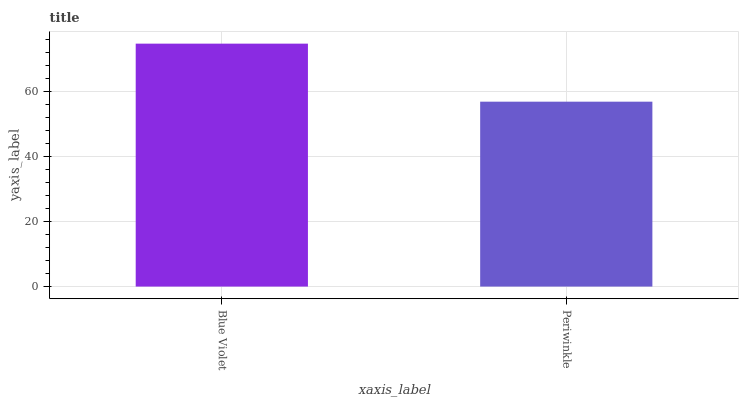Is Periwinkle the minimum?
Answer yes or no. Yes. Is Blue Violet the maximum?
Answer yes or no. Yes. Is Periwinkle the maximum?
Answer yes or no. No. Is Blue Violet greater than Periwinkle?
Answer yes or no. Yes. Is Periwinkle less than Blue Violet?
Answer yes or no. Yes. Is Periwinkle greater than Blue Violet?
Answer yes or no. No. Is Blue Violet less than Periwinkle?
Answer yes or no. No. Is Blue Violet the high median?
Answer yes or no. Yes. Is Periwinkle the low median?
Answer yes or no. Yes. Is Periwinkle the high median?
Answer yes or no. No. Is Blue Violet the low median?
Answer yes or no. No. 